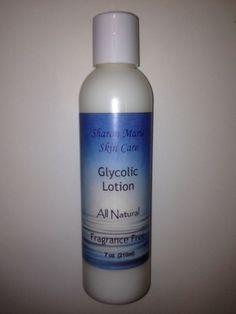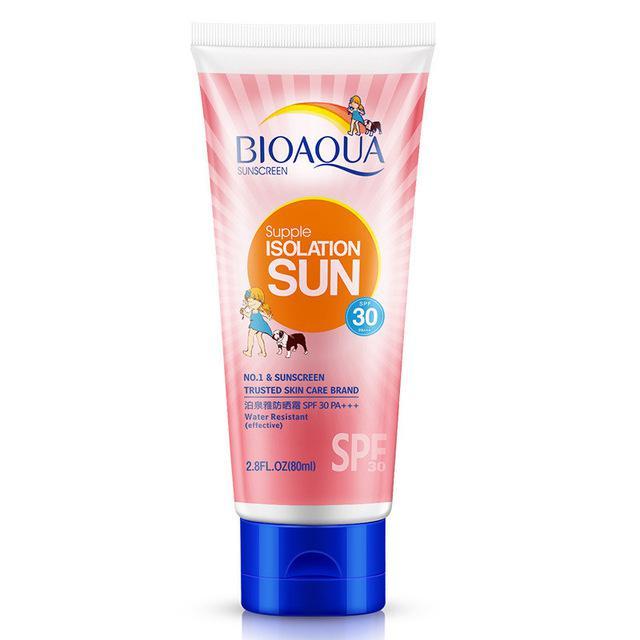The first image is the image on the left, the second image is the image on the right. For the images displayed, is the sentence "The left image contains no more than two skincare products, and includes at least one pump-top bottle with its nozzle facing rightward." factually correct? Answer yes or no. No. The first image is the image on the left, the second image is the image on the right. For the images shown, is this caption "The left image contains at least two ointment containers." true? Answer yes or no. No. 